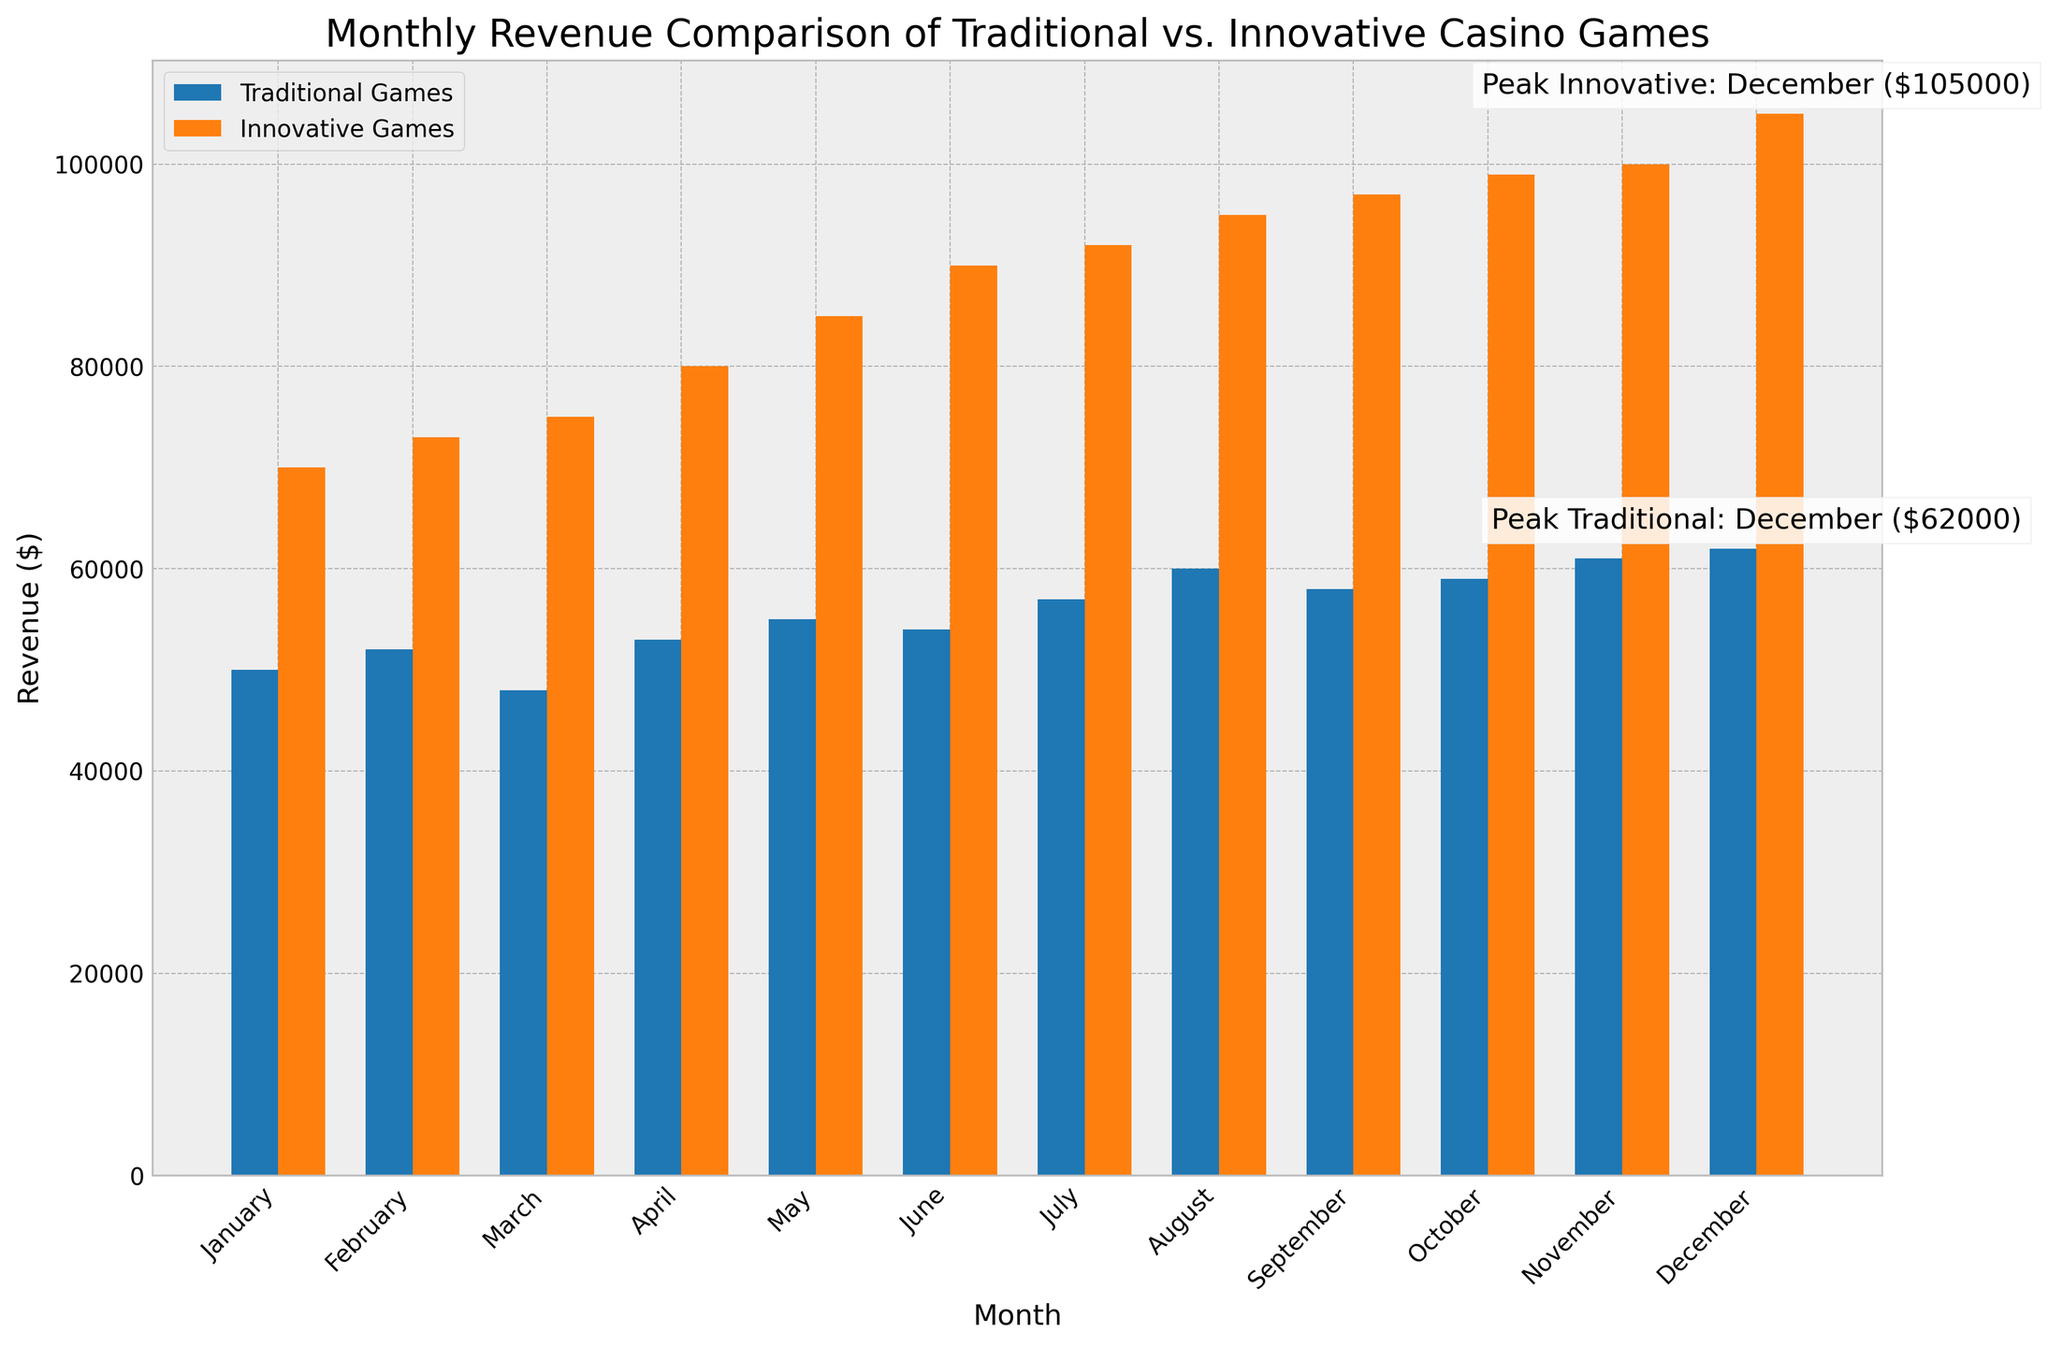What is the highest monthly revenue for Innovative Games as shown in the figure? The annotation and the height of the orange bar for the month of December indicate that it has the highest revenue for Innovative Games, which is $105,000.
Answer: $105,000 Which month has the peak revenue for Traditional Games as per the figure? The text annotation next to the tallest blue bar points to December as the month with the peak revenue for Traditional Games.
Answer: December What is the difference in revenue between Traditional and Innovative Games for June? The chart shows revenue of $54,000 for Traditional Games and $90,000 for Innovative Games in June. The difference is calculated as $90,000 - $54,000.
Answer: $36,000 How does the revenue of Traditional Games in October compare to Innovative Games in the same month? The height of the bars in October shows that Traditional Games have a revenue of $59,000 while Innovative Games have $99,000, meaning Innovative Games have a higher revenue.
Answer: Innovative Games have higher revenue What is the revenue trend for Innovative Games over the months? The orange bars representing Innovative Games' revenue consistently increase in height from January to December, indicating a steady upward trend over the months.
Answer: Increasing trend By what margin is the highest monthly revenue of Innovative Games greater than that of Traditional Games? The highest monthly revenue of Innovative Games is $105,000 (December), and for Traditional Games, it is $62,000 (December). The margin is calculated as $105,000 - $62,000.
Answer: $43,000 What is the average monthly revenue for Traditional Games as per the figure? To calculate the average: Sum all the monthly revenues for Traditional Games ($50,000 + $52,000 + $48,000 + $53,000 + $55,000 + $54,000 + $57,000 + $60,000 + $58,000 + $59,000 + $61,000 + $62,000) and then divide by 12. This gives an average of $53,083.33.
Answer: $53,083.33 Which month shows the smallest difference in revenue between Traditional and Innovative Games? Subtract the revenue of Traditional Games from Innovative Games for each month; July has the smallest difference as the figures are $92,000 and $57,000 for Innovative and Traditional Games respectively, giving a difference of $35,000.
Answer: July How many months display a revenue of over $90,000 for Innovative Games according to the chart? The chart shows that Innovative Games have revenues above $90,000 for June, July, August, September, October, November, and December. This counts to 7 months.
Answer: 7 